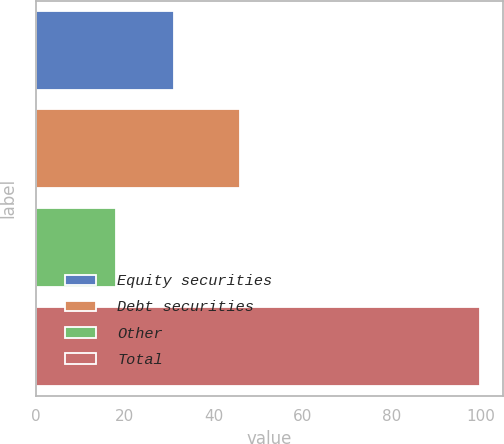<chart> <loc_0><loc_0><loc_500><loc_500><bar_chart><fcel>Equity securities<fcel>Debt securities<fcel>Other<fcel>Total<nl><fcel>31<fcel>46<fcel>18<fcel>100<nl></chart> 